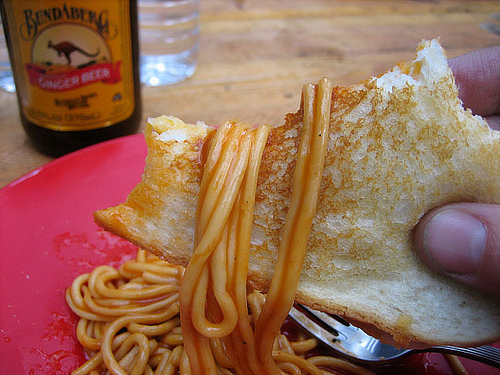Please transcribe the text in this image. BUNDABERG 